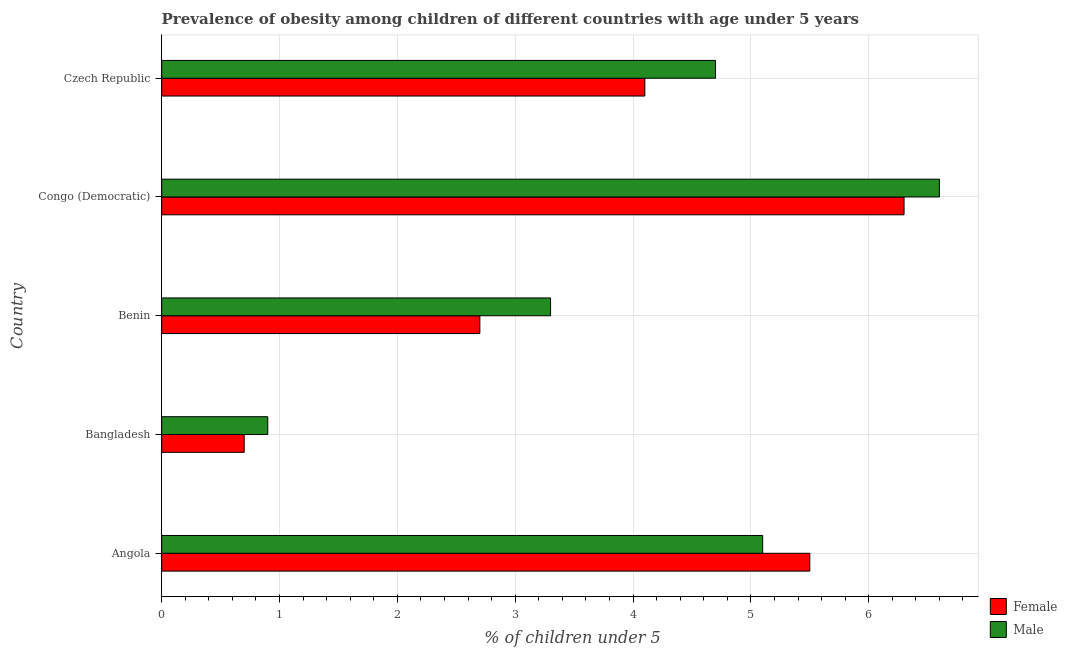How many bars are there on the 2nd tick from the bottom?
Give a very brief answer. 2. What is the label of the 3rd group of bars from the top?
Make the answer very short. Benin. In how many cases, is the number of bars for a given country not equal to the number of legend labels?
Your response must be concise. 0. What is the percentage of obese male children in Congo (Democratic)?
Make the answer very short. 6.6. Across all countries, what is the maximum percentage of obese male children?
Your answer should be very brief. 6.6. Across all countries, what is the minimum percentage of obese female children?
Keep it short and to the point. 0.7. In which country was the percentage of obese female children maximum?
Provide a succinct answer. Congo (Democratic). In which country was the percentage of obese male children minimum?
Provide a succinct answer. Bangladesh. What is the total percentage of obese female children in the graph?
Give a very brief answer. 19.3. What is the difference between the percentage of obese female children in Bangladesh and the percentage of obese male children in Czech Republic?
Offer a terse response. -4. What is the average percentage of obese male children per country?
Provide a succinct answer. 4.12. What is the difference between the percentage of obese female children and percentage of obese male children in Benin?
Give a very brief answer. -0.6. What is the ratio of the percentage of obese female children in Bangladesh to that in Benin?
Provide a short and direct response. 0.26. Is the percentage of obese female children in Benin less than that in Czech Republic?
Offer a terse response. Yes. Is the difference between the percentage of obese male children in Bangladesh and Benin greater than the difference between the percentage of obese female children in Bangladesh and Benin?
Provide a succinct answer. No. What is the difference between the highest and the lowest percentage of obese female children?
Offer a terse response. 5.6. What does the 2nd bar from the bottom in Czech Republic represents?
Provide a succinct answer. Male. How many bars are there?
Ensure brevity in your answer.  10. How many countries are there in the graph?
Your response must be concise. 5. Does the graph contain grids?
Offer a very short reply. Yes. Where does the legend appear in the graph?
Offer a very short reply. Bottom right. How many legend labels are there?
Provide a short and direct response. 2. How are the legend labels stacked?
Ensure brevity in your answer.  Vertical. What is the title of the graph?
Provide a succinct answer. Prevalence of obesity among children of different countries with age under 5 years. Does "Private creditors" appear as one of the legend labels in the graph?
Give a very brief answer. No. What is the label or title of the X-axis?
Ensure brevity in your answer.   % of children under 5. What is the label or title of the Y-axis?
Your answer should be compact. Country. What is the  % of children under 5 of Female in Angola?
Provide a short and direct response. 5.5. What is the  % of children under 5 of Male in Angola?
Give a very brief answer. 5.1. What is the  % of children under 5 in Female in Bangladesh?
Provide a short and direct response. 0.7. What is the  % of children under 5 in Male in Bangladesh?
Keep it short and to the point. 0.9. What is the  % of children under 5 in Female in Benin?
Your response must be concise. 2.7. What is the  % of children under 5 of Male in Benin?
Your answer should be very brief. 3.3. What is the  % of children under 5 in Female in Congo (Democratic)?
Make the answer very short. 6.3. What is the  % of children under 5 of Male in Congo (Democratic)?
Keep it short and to the point. 6.6. What is the  % of children under 5 of Female in Czech Republic?
Offer a terse response. 4.1. What is the  % of children under 5 in Male in Czech Republic?
Offer a very short reply. 4.7. Across all countries, what is the maximum  % of children under 5 in Female?
Offer a very short reply. 6.3. Across all countries, what is the maximum  % of children under 5 of Male?
Your response must be concise. 6.6. Across all countries, what is the minimum  % of children under 5 in Female?
Your response must be concise. 0.7. Across all countries, what is the minimum  % of children under 5 in Male?
Offer a terse response. 0.9. What is the total  % of children under 5 of Female in the graph?
Your response must be concise. 19.3. What is the total  % of children under 5 of Male in the graph?
Offer a terse response. 20.6. What is the difference between the  % of children under 5 in Female in Angola and that in Benin?
Your response must be concise. 2.8. What is the difference between the  % of children under 5 of Female in Bangladesh and that in Benin?
Offer a terse response. -2. What is the difference between the  % of children under 5 in Male in Bangladesh and that in Benin?
Keep it short and to the point. -2.4. What is the difference between the  % of children under 5 in Female in Bangladesh and that in Congo (Democratic)?
Give a very brief answer. -5.6. What is the difference between the  % of children under 5 of Male in Bangladesh and that in Czech Republic?
Your response must be concise. -3.8. What is the difference between the  % of children under 5 in Female in Benin and that in Congo (Democratic)?
Provide a short and direct response. -3.6. What is the difference between the  % of children under 5 in Male in Congo (Democratic) and that in Czech Republic?
Your response must be concise. 1.9. What is the difference between the  % of children under 5 in Female in Angola and the  % of children under 5 in Male in Bangladesh?
Your response must be concise. 4.6. What is the difference between the  % of children under 5 in Female in Angola and the  % of children under 5 in Male in Czech Republic?
Give a very brief answer. 0.8. What is the difference between the  % of children under 5 of Female in Bangladesh and the  % of children under 5 of Male in Congo (Democratic)?
Offer a terse response. -5.9. What is the difference between the  % of children under 5 in Female in Bangladesh and the  % of children under 5 in Male in Czech Republic?
Offer a terse response. -4. What is the difference between the  % of children under 5 of Female in Benin and the  % of children under 5 of Male in Congo (Democratic)?
Make the answer very short. -3.9. What is the difference between the  % of children under 5 in Female in Congo (Democratic) and the  % of children under 5 in Male in Czech Republic?
Keep it short and to the point. 1.6. What is the average  % of children under 5 of Female per country?
Ensure brevity in your answer.  3.86. What is the average  % of children under 5 of Male per country?
Your answer should be very brief. 4.12. What is the difference between the  % of children under 5 in Female and  % of children under 5 in Male in Angola?
Your answer should be very brief. 0.4. What is the ratio of the  % of children under 5 of Female in Angola to that in Bangladesh?
Your answer should be compact. 7.86. What is the ratio of the  % of children under 5 of Male in Angola to that in Bangladesh?
Keep it short and to the point. 5.67. What is the ratio of the  % of children under 5 in Female in Angola to that in Benin?
Make the answer very short. 2.04. What is the ratio of the  % of children under 5 of Male in Angola to that in Benin?
Offer a very short reply. 1.55. What is the ratio of the  % of children under 5 in Female in Angola to that in Congo (Democratic)?
Your answer should be very brief. 0.87. What is the ratio of the  % of children under 5 of Male in Angola to that in Congo (Democratic)?
Provide a short and direct response. 0.77. What is the ratio of the  % of children under 5 in Female in Angola to that in Czech Republic?
Offer a terse response. 1.34. What is the ratio of the  % of children under 5 in Male in Angola to that in Czech Republic?
Your answer should be compact. 1.09. What is the ratio of the  % of children under 5 of Female in Bangladesh to that in Benin?
Provide a short and direct response. 0.26. What is the ratio of the  % of children under 5 of Male in Bangladesh to that in Benin?
Your answer should be very brief. 0.27. What is the ratio of the  % of children under 5 of Male in Bangladesh to that in Congo (Democratic)?
Your answer should be very brief. 0.14. What is the ratio of the  % of children under 5 of Female in Bangladesh to that in Czech Republic?
Make the answer very short. 0.17. What is the ratio of the  % of children under 5 of Male in Bangladesh to that in Czech Republic?
Provide a succinct answer. 0.19. What is the ratio of the  % of children under 5 of Female in Benin to that in Congo (Democratic)?
Make the answer very short. 0.43. What is the ratio of the  % of children under 5 in Male in Benin to that in Congo (Democratic)?
Make the answer very short. 0.5. What is the ratio of the  % of children under 5 of Female in Benin to that in Czech Republic?
Offer a very short reply. 0.66. What is the ratio of the  % of children under 5 in Male in Benin to that in Czech Republic?
Your response must be concise. 0.7. What is the ratio of the  % of children under 5 of Female in Congo (Democratic) to that in Czech Republic?
Ensure brevity in your answer.  1.54. What is the ratio of the  % of children under 5 in Male in Congo (Democratic) to that in Czech Republic?
Provide a short and direct response. 1.4. What is the difference between the highest and the second highest  % of children under 5 of Male?
Ensure brevity in your answer.  1.5. What is the difference between the highest and the lowest  % of children under 5 in Female?
Your response must be concise. 5.6. What is the difference between the highest and the lowest  % of children under 5 in Male?
Keep it short and to the point. 5.7. 